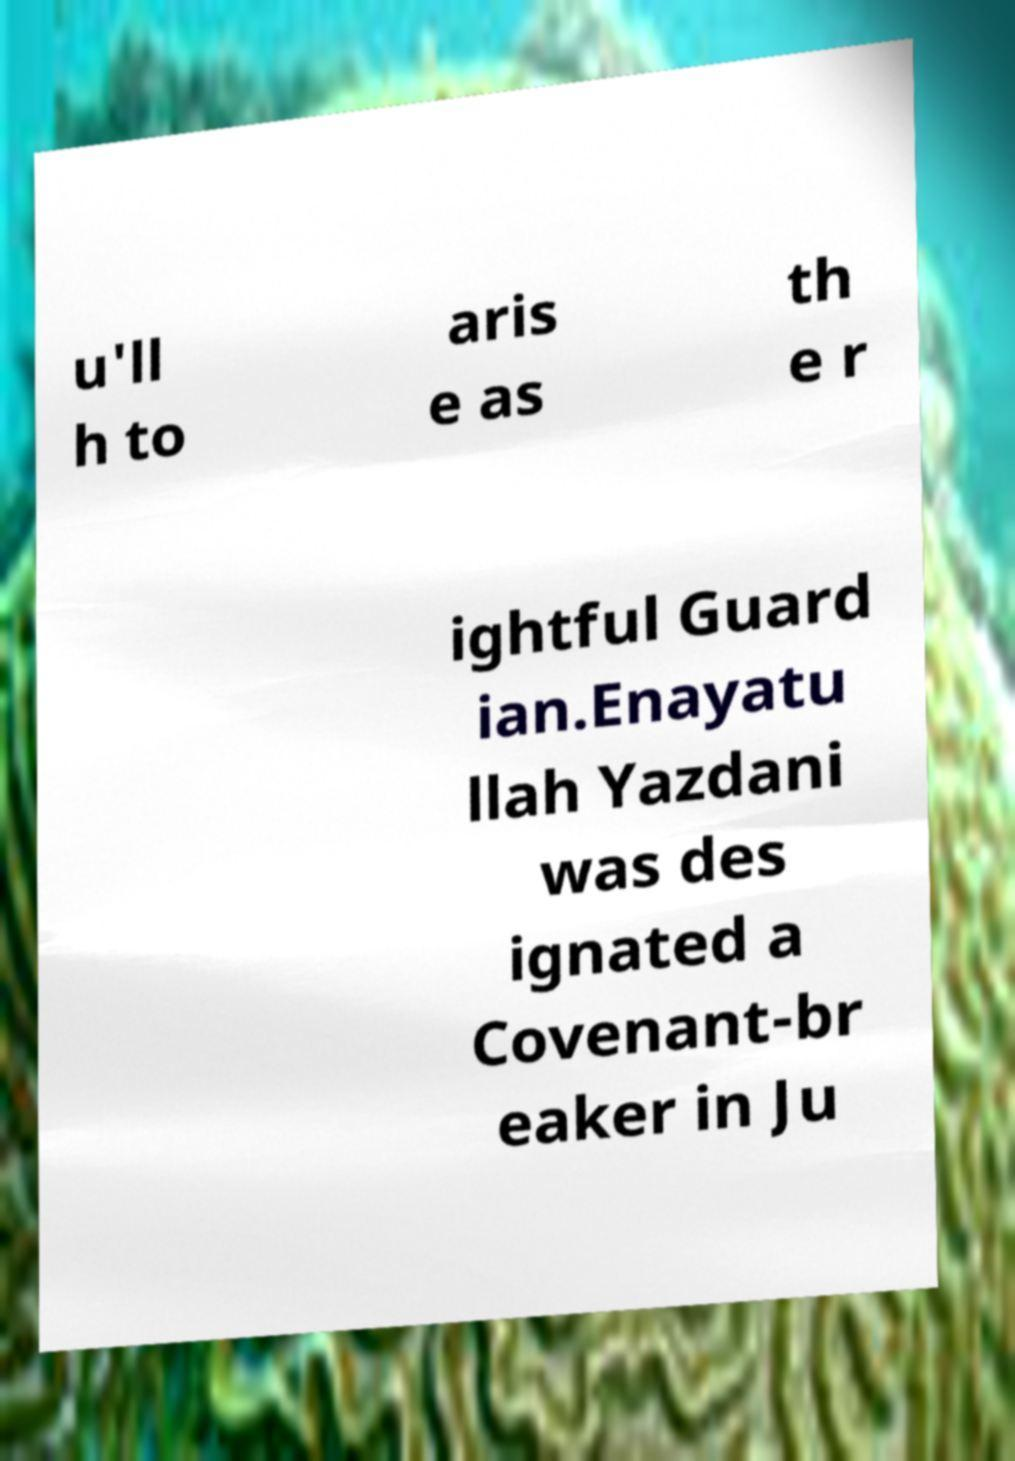Please identify and transcribe the text found in this image. u'll h to aris e as th e r ightful Guard ian.Enayatu llah Yazdani was des ignated a Covenant-br eaker in Ju 